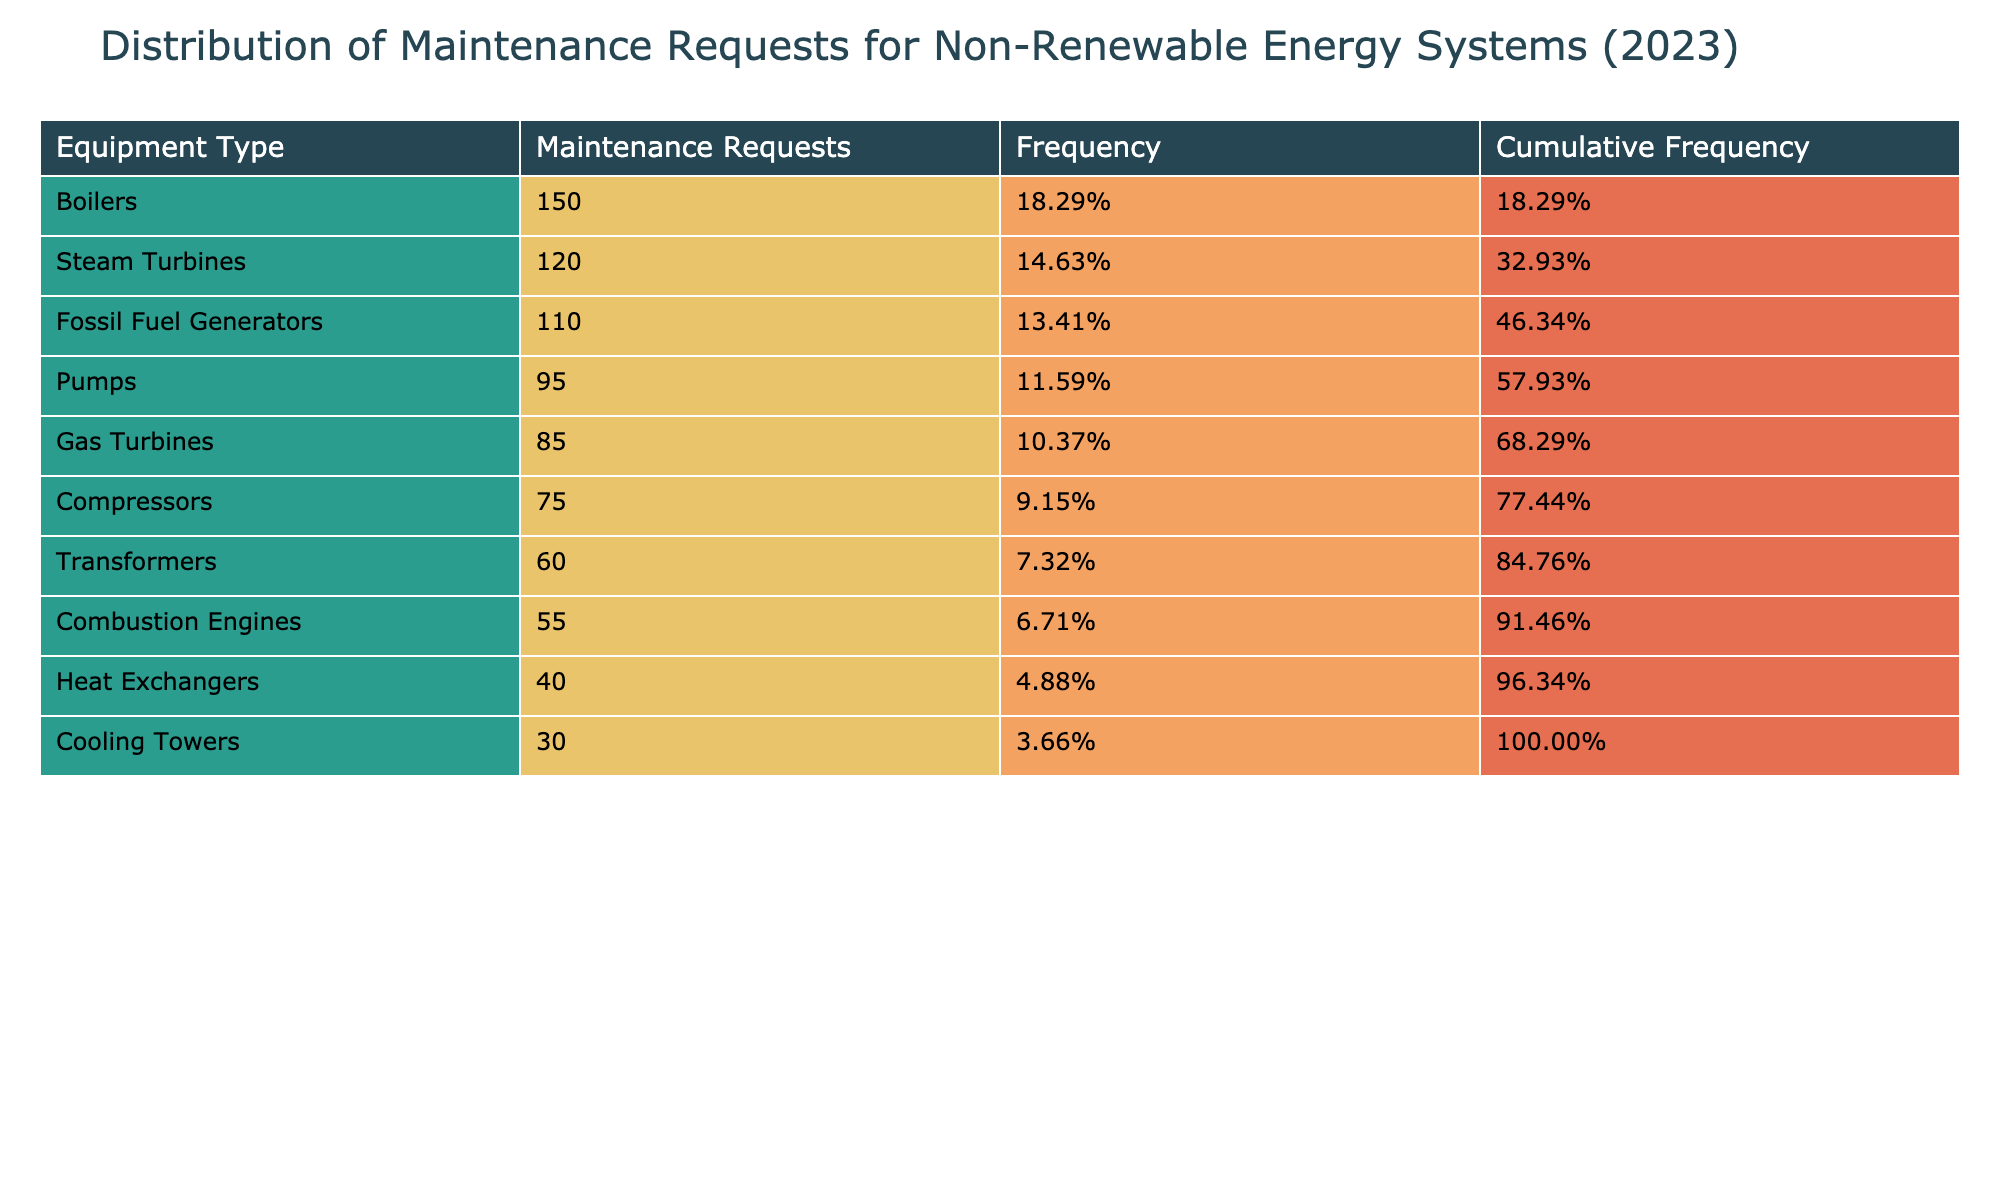What is the total number of maintenance requests for all equipment types? To find the total, we sum up the maintenance requests for each equipment type listed in the table: 120 + 85 + 150 + 60 + 95 + 75 + 40 + 55 + 30 + 110 = 970.
Answer: 970 Which equipment type had the highest number of maintenance requests? By examining the table, we find that Boilers had the highest maintenance requests with a count of 150.
Answer: Boilers Is the number of maintenance requests for Pumps greater than that for Transformers? Looking at the values, Pumps received 95 maintenance requests while Transformers received 60, indicating that Pump requests are indeed higher.
Answer: Yes What is the cumulative frequency for Gas Turbines? The table shows Gas Turbines with 85 maintenance requests. To find cumulative frequency, we add the frequencies of all equipment types above it: 120 (Steam Turbines) + 85 (Gas Turbines) = 205. Then, we determine the total frequency which is 970. Cumulative frequency is therefore calculated as (205 / 970) = 0.211 rounded to two decimal places gives 21.1%.
Answer: 21.1% What is the average number of maintenance requests for the equipment listed in the table? To find the average, we sum all maintenance requests (970) and divide by the number of equipment types (10): 970 / 10 = 97.
Answer: 97 Does the maintenance request count for Cooling Towers exceed that of Combustion Engines? Cooling Towers have 30 requests and Combustion Engines have 55 requests. Since 30 is less than 55, the statement is false.
Answer: No What is the difference in maintenance requests between the equipment type with the most requests and the one with the least requests? The equipment type with the most requests is Boilers at 150, and the least is Cooling Towers at 30. The difference is calculated as 150 - 30 = 120.
Answer: 120 How much percentage of total maintenance requests do the Fossil Fuel Generators represent? Fossil Fuel Generators had 110 requests. To find the percentage, we calculate (110 / 970) x 100 = 11.34%.
Answer: 11.34% What is the second most requested equipment type based on the maintenance requests? Reviewing the maintenance requests, the ranking places Boilers at 150 (first), and Steam Turbines at 120 (second). Therefore, Steam Turbines is the second most requested type.
Answer: Steam Turbines 